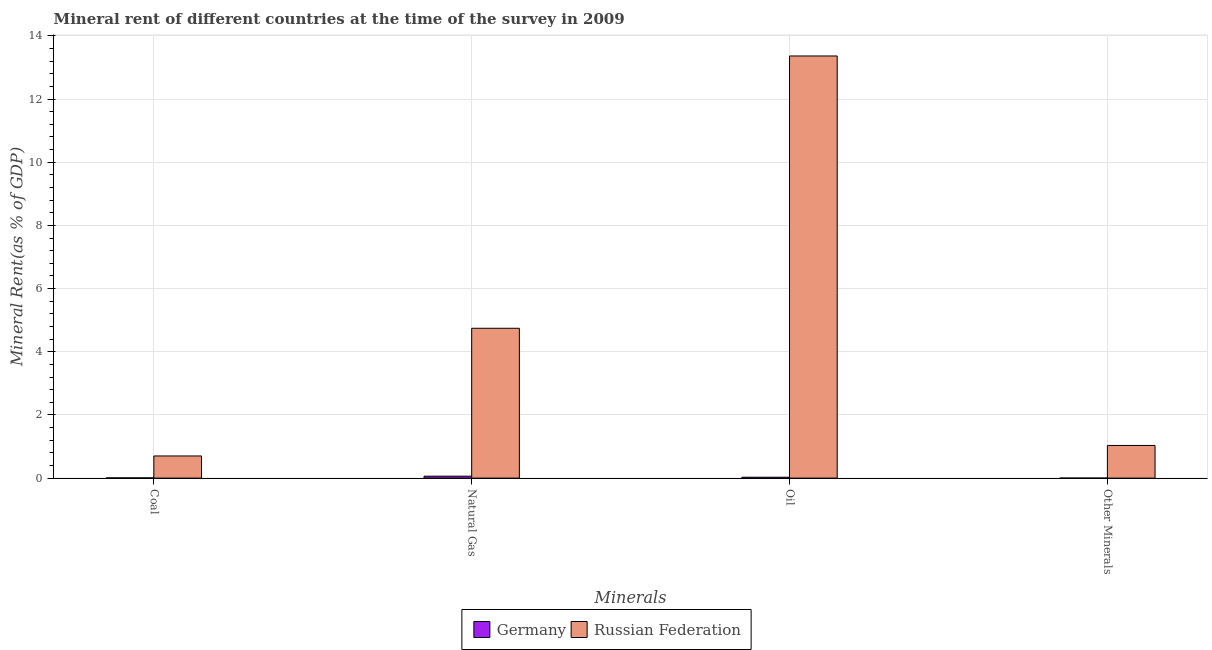How many groups of bars are there?
Your answer should be compact. 4. Are the number of bars on each tick of the X-axis equal?
Keep it short and to the point. Yes. What is the label of the 2nd group of bars from the left?
Provide a short and direct response. Natural Gas. What is the coal rent in Germany?
Keep it short and to the point. 0.01. Across all countries, what is the maximum  rent of other minerals?
Ensure brevity in your answer.  1.03. Across all countries, what is the minimum oil rent?
Give a very brief answer. 0.03. In which country was the  rent of other minerals maximum?
Offer a very short reply. Russian Federation. What is the total natural gas rent in the graph?
Provide a succinct answer. 4.8. What is the difference between the  rent of other minerals in Russian Federation and that in Germany?
Keep it short and to the point. 1.03. What is the difference between the  rent of other minerals in Germany and the coal rent in Russian Federation?
Offer a terse response. -0.7. What is the average natural gas rent per country?
Offer a terse response. 2.4. What is the difference between the  rent of other minerals and coal rent in Russian Federation?
Your answer should be compact. 0.33. In how many countries, is the oil rent greater than 10.4 %?
Provide a succinct answer. 1. What is the ratio of the natural gas rent in Germany to that in Russian Federation?
Offer a terse response. 0.01. What is the difference between the highest and the second highest oil rent?
Make the answer very short. 13.33. What is the difference between the highest and the lowest  rent of other minerals?
Provide a short and direct response. 1.03. In how many countries, is the oil rent greater than the average oil rent taken over all countries?
Your answer should be compact. 1. What does the 2nd bar from the left in Other Minerals represents?
Your answer should be compact. Russian Federation. What does the 2nd bar from the right in Other Minerals represents?
Provide a short and direct response. Germany. Is it the case that in every country, the sum of the coal rent and natural gas rent is greater than the oil rent?
Offer a very short reply. No. How many bars are there?
Offer a terse response. 8. Are all the bars in the graph horizontal?
Provide a succinct answer. No. Does the graph contain any zero values?
Offer a very short reply. No. How many legend labels are there?
Make the answer very short. 2. What is the title of the graph?
Keep it short and to the point. Mineral rent of different countries at the time of the survey in 2009. What is the label or title of the X-axis?
Keep it short and to the point. Minerals. What is the label or title of the Y-axis?
Ensure brevity in your answer.  Mineral Rent(as % of GDP). What is the Mineral Rent(as % of GDP) of Germany in Coal?
Provide a short and direct response. 0.01. What is the Mineral Rent(as % of GDP) in Russian Federation in Coal?
Make the answer very short. 0.7. What is the Mineral Rent(as % of GDP) in Germany in Natural Gas?
Provide a succinct answer. 0.06. What is the Mineral Rent(as % of GDP) of Russian Federation in Natural Gas?
Provide a short and direct response. 4.74. What is the Mineral Rent(as % of GDP) in Germany in Oil?
Your response must be concise. 0.03. What is the Mineral Rent(as % of GDP) in Russian Federation in Oil?
Give a very brief answer. 13.36. What is the Mineral Rent(as % of GDP) of Germany in Other Minerals?
Give a very brief answer. 0. What is the Mineral Rent(as % of GDP) in Russian Federation in Other Minerals?
Your response must be concise. 1.03. Across all Minerals, what is the maximum Mineral Rent(as % of GDP) of Germany?
Provide a succinct answer. 0.06. Across all Minerals, what is the maximum Mineral Rent(as % of GDP) in Russian Federation?
Give a very brief answer. 13.36. Across all Minerals, what is the minimum Mineral Rent(as % of GDP) of Germany?
Keep it short and to the point. 0. Across all Minerals, what is the minimum Mineral Rent(as % of GDP) of Russian Federation?
Provide a short and direct response. 0.7. What is the total Mineral Rent(as % of GDP) of Germany in the graph?
Offer a terse response. 0.1. What is the total Mineral Rent(as % of GDP) in Russian Federation in the graph?
Provide a succinct answer. 19.84. What is the difference between the Mineral Rent(as % of GDP) of Germany in Coal and that in Natural Gas?
Your response must be concise. -0.05. What is the difference between the Mineral Rent(as % of GDP) of Russian Federation in Coal and that in Natural Gas?
Provide a succinct answer. -4.04. What is the difference between the Mineral Rent(as % of GDP) in Germany in Coal and that in Oil?
Your answer should be compact. -0.02. What is the difference between the Mineral Rent(as % of GDP) of Russian Federation in Coal and that in Oil?
Ensure brevity in your answer.  -12.66. What is the difference between the Mineral Rent(as % of GDP) of Germany in Coal and that in Other Minerals?
Keep it short and to the point. 0.01. What is the difference between the Mineral Rent(as % of GDP) in Russian Federation in Coal and that in Other Minerals?
Offer a very short reply. -0.33. What is the difference between the Mineral Rent(as % of GDP) of Germany in Natural Gas and that in Oil?
Ensure brevity in your answer.  0.03. What is the difference between the Mineral Rent(as % of GDP) in Russian Federation in Natural Gas and that in Oil?
Provide a short and direct response. -8.62. What is the difference between the Mineral Rent(as % of GDP) of Germany in Natural Gas and that in Other Minerals?
Offer a very short reply. 0.06. What is the difference between the Mineral Rent(as % of GDP) in Russian Federation in Natural Gas and that in Other Minerals?
Provide a succinct answer. 3.71. What is the difference between the Mineral Rent(as % of GDP) of Germany in Oil and that in Other Minerals?
Keep it short and to the point. 0.03. What is the difference between the Mineral Rent(as % of GDP) of Russian Federation in Oil and that in Other Minerals?
Your response must be concise. 12.33. What is the difference between the Mineral Rent(as % of GDP) in Germany in Coal and the Mineral Rent(as % of GDP) in Russian Federation in Natural Gas?
Your answer should be compact. -4.74. What is the difference between the Mineral Rent(as % of GDP) in Germany in Coal and the Mineral Rent(as % of GDP) in Russian Federation in Oil?
Your response must be concise. -13.35. What is the difference between the Mineral Rent(as % of GDP) in Germany in Coal and the Mineral Rent(as % of GDP) in Russian Federation in Other Minerals?
Give a very brief answer. -1.03. What is the difference between the Mineral Rent(as % of GDP) in Germany in Natural Gas and the Mineral Rent(as % of GDP) in Russian Federation in Oil?
Provide a short and direct response. -13.3. What is the difference between the Mineral Rent(as % of GDP) in Germany in Natural Gas and the Mineral Rent(as % of GDP) in Russian Federation in Other Minerals?
Offer a very short reply. -0.97. What is the difference between the Mineral Rent(as % of GDP) in Germany in Oil and the Mineral Rent(as % of GDP) in Russian Federation in Other Minerals?
Ensure brevity in your answer.  -1.01. What is the average Mineral Rent(as % of GDP) of Germany per Minerals?
Your response must be concise. 0.02. What is the average Mineral Rent(as % of GDP) of Russian Federation per Minerals?
Ensure brevity in your answer.  4.96. What is the difference between the Mineral Rent(as % of GDP) of Germany and Mineral Rent(as % of GDP) of Russian Federation in Coal?
Provide a short and direct response. -0.69. What is the difference between the Mineral Rent(as % of GDP) of Germany and Mineral Rent(as % of GDP) of Russian Federation in Natural Gas?
Ensure brevity in your answer.  -4.68. What is the difference between the Mineral Rent(as % of GDP) of Germany and Mineral Rent(as % of GDP) of Russian Federation in Oil?
Keep it short and to the point. -13.33. What is the difference between the Mineral Rent(as % of GDP) of Germany and Mineral Rent(as % of GDP) of Russian Federation in Other Minerals?
Offer a very short reply. -1.03. What is the ratio of the Mineral Rent(as % of GDP) of Germany in Coal to that in Natural Gas?
Ensure brevity in your answer.  0.12. What is the ratio of the Mineral Rent(as % of GDP) in Russian Federation in Coal to that in Natural Gas?
Keep it short and to the point. 0.15. What is the ratio of the Mineral Rent(as % of GDP) of Germany in Coal to that in Oil?
Give a very brief answer. 0.26. What is the ratio of the Mineral Rent(as % of GDP) of Russian Federation in Coal to that in Oil?
Offer a very short reply. 0.05. What is the ratio of the Mineral Rent(as % of GDP) of Germany in Coal to that in Other Minerals?
Keep it short and to the point. 18.5. What is the ratio of the Mineral Rent(as % of GDP) of Russian Federation in Coal to that in Other Minerals?
Ensure brevity in your answer.  0.68. What is the ratio of the Mineral Rent(as % of GDP) of Germany in Natural Gas to that in Oil?
Keep it short and to the point. 2.17. What is the ratio of the Mineral Rent(as % of GDP) in Russian Federation in Natural Gas to that in Oil?
Keep it short and to the point. 0.35. What is the ratio of the Mineral Rent(as % of GDP) in Germany in Natural Gas to that in Other Minerals?
Provide a short and direct response. 152.33. What is the ratio of the Mineral Rent(as % of GDP) of Russian Federation in Natural Gas to that in Other Minerals?
Your answer should be compact. 4.59. What is the ratio of the Mineral Rent(as % of GDP) of Germany in Oil to that in Other Minerals?
Keep it short and to the point. 70.15. What is the ratio of the Mineral Rent(as % of GDP) in Russian Federation in Oil to that in Other Minerals?
Your answer should be compact. 12.92. What is the difference between the highest and the second highest Mineral Rent(as % of GDP) in Germany?
Ensure brevity in your answer.  0.03. What is the difference between the highest and the second highest Mineral Rent(as % of GDP) of Russian Federation?
Your answer should be very brief. 8.62. What is the difference between the highest and the lowest Mineral Rent(as % of GDP) in Germany?
Offer a very short reply. 0.06. What is the difference between the highest and the lowest Mineral Rent(as % of GDP) in Russian Federation?
Offer a terse response. 12.66. 